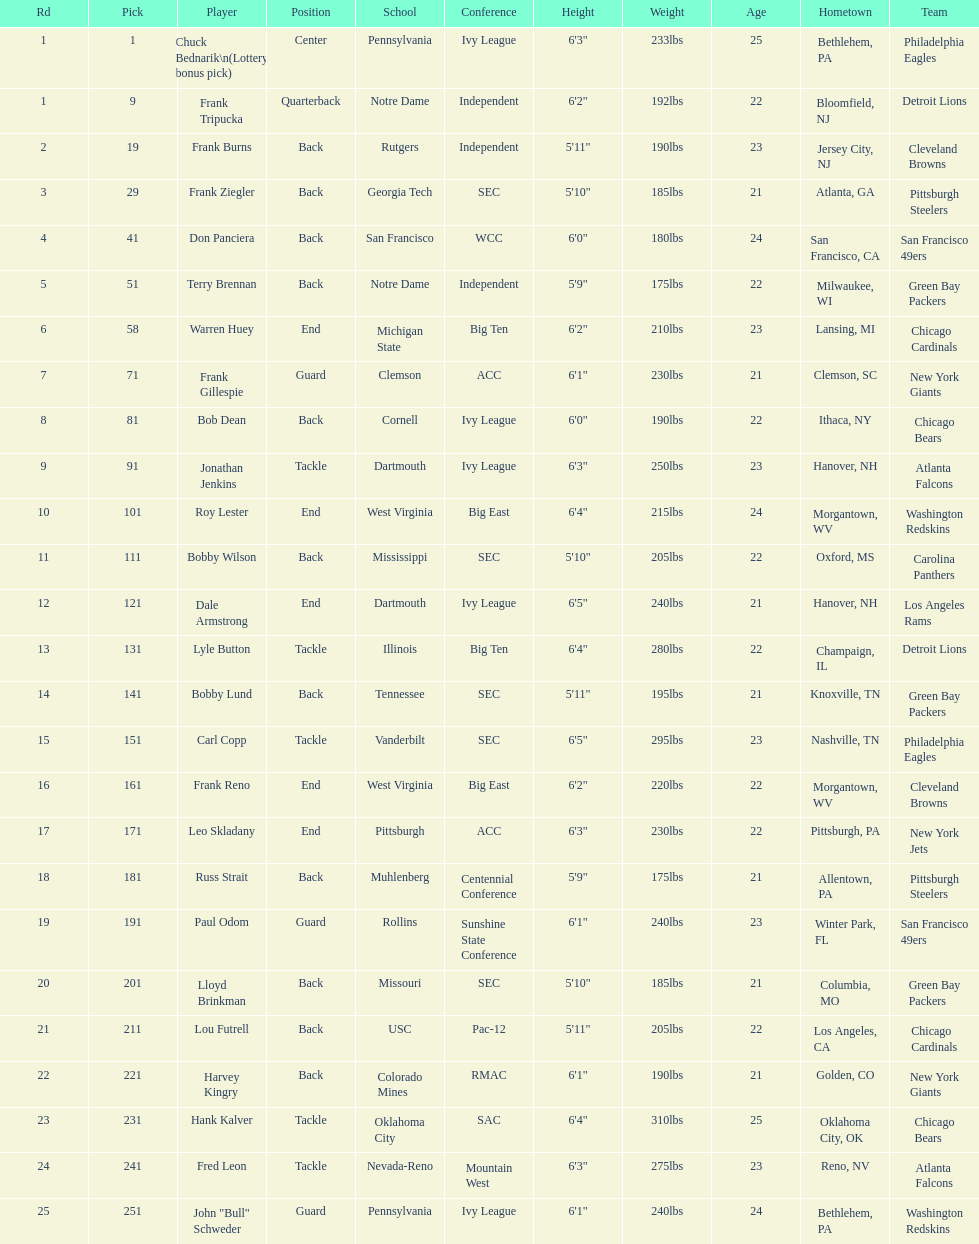Most prevalent school Pennsylvania. 